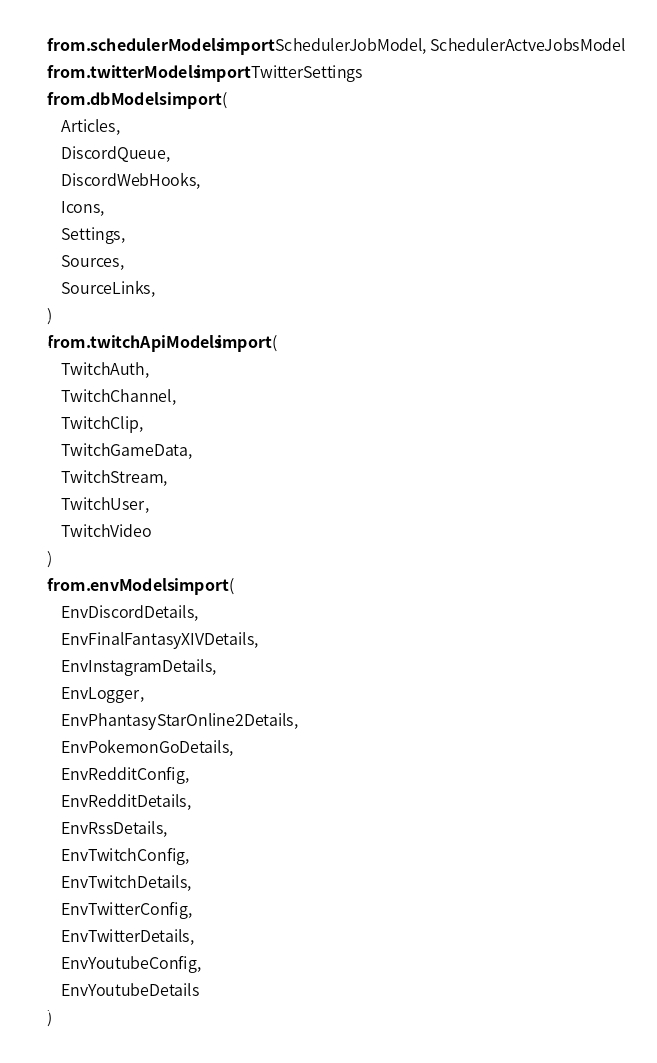Convert code to text. <code><loc_0><loc_0><loc_500><loc_500><_Python_>from .schedulerModels import SchedulerJobModel, SchedulerActveJobsModel
from .twitterModels import TwitterSettings
from .dbModels import (
    Articles,
    DiscordQueue,
    DiscordWebHooks,
    Icons,
    Settings,
    Sources,
    SourceLinks,
)
from .twitchApiModels import (
    TwitchAuth,
    TwitchChannel,
    TwitchClip,
    TwitchGameData,
    TwitchStream,
    TwitchUser,
    TwitchVideo
)
from .envModels import (
    EnvDiscordDetails,
    EnvFinalFantasyXIVDetails,
    EnvInstagramDetails,
    EnvLogger,
    EnvPhantasyStarOnline2Details,
    EnvPokemonGoDetails,
    EnvRedditConfig,
    EnvRedditDetails,
    EnvRssDetails,
    EnvTwitchConfig,
    EnvTwitchDetails,
    EnvTwitterConfig,
    EnvTwitterDetails,
    EnvYoutubeConfig,
    EnvYoutubeDetails
)
</code> 